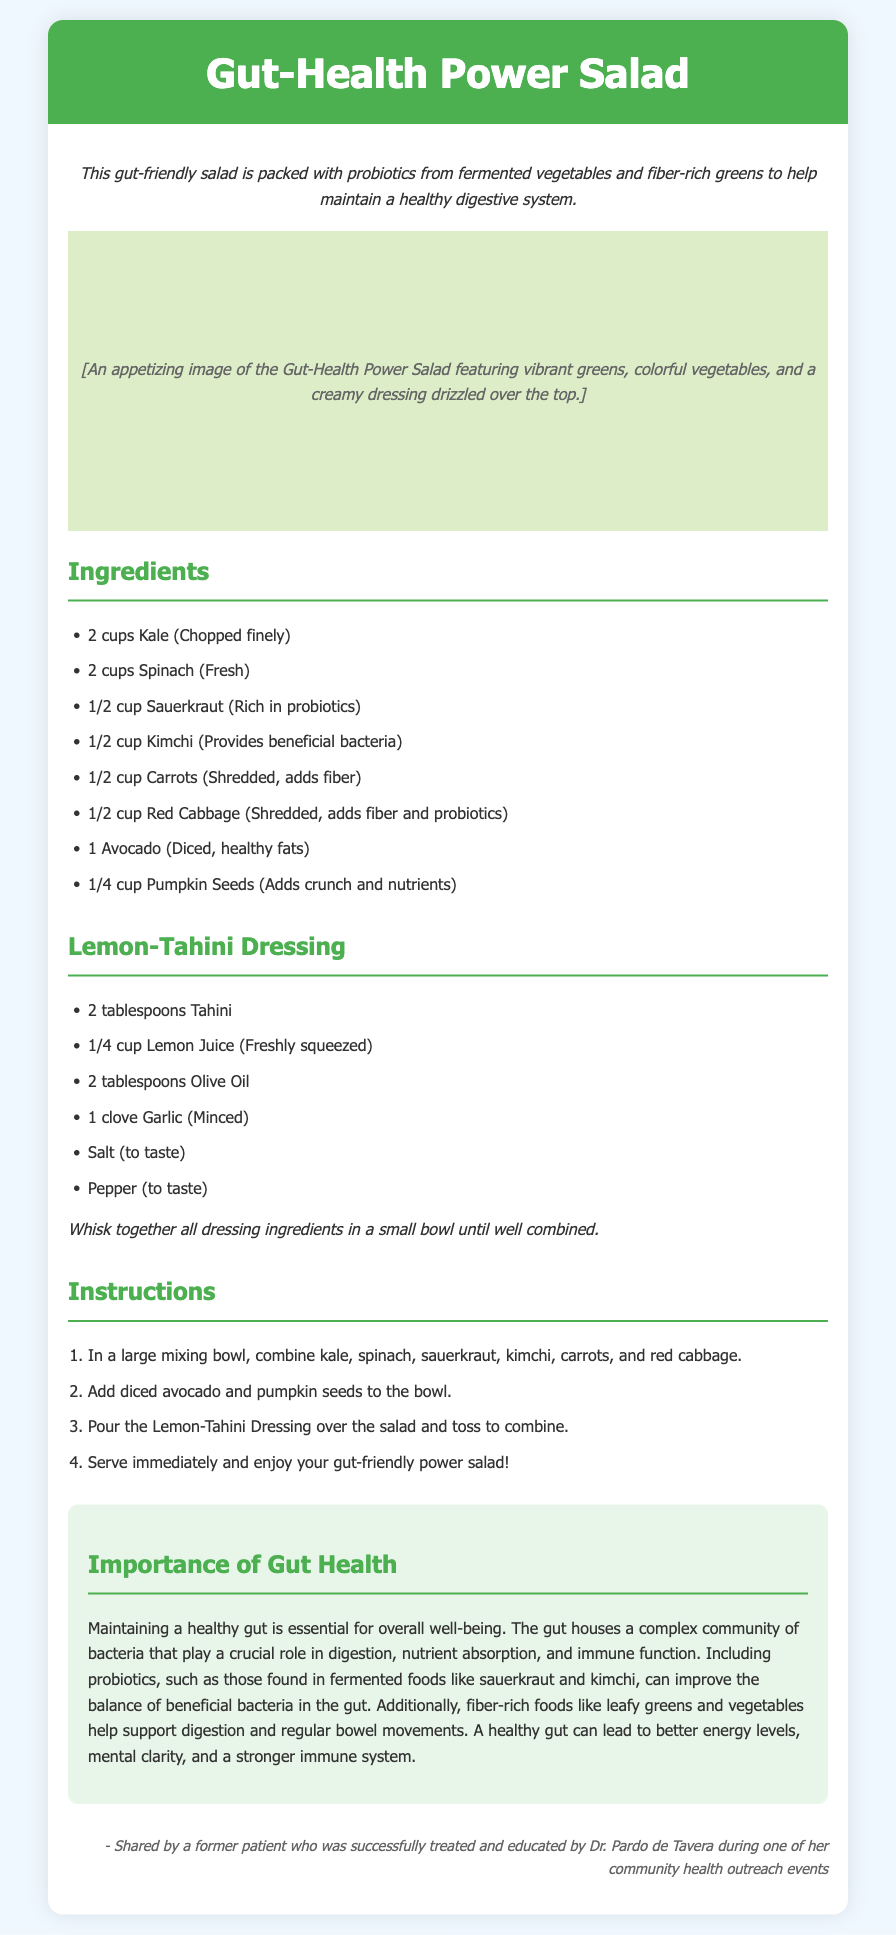what is the main ingredient that provides probiotics? Sauerkraut and kimchi are both listed as ingredients that are rich in probiotics.
Answer: Sauerkraut, Kimchi how many cups of kale are needed? The recipe specifies using 2 cups of chopped kale.
Answer: 2 cups what is the dressing used for the salad? The dressing is called Lemon-Tahini Dressing, which includes tahini, lemon juice, olive oil, and garlic.
Answer: Lemon-Tahini Dressing how many ingredients are listed in total for the salad? The ingredients section lists 8 main salad ingredients and 6 dressing ingredients, totaling 14.
Answer: 14 what is the importance of gut health mentioned? The document emphasizes that maintaining a healthy gut is essential for digestion, nutrient absorption, and immune function.
Answer: Essential for digestion, nutrient absorption, and immune function what ingredient adds healthy fats to the salad? The recipe includes diced avocado, which is known for its healthy fats.
Answer: Avocado how should the dressing be prepared? The instructions state to whisk together the dressing ingredients until well combined.
Answer: Whisk together what type of greens are included in the recipe? The recipe includes kale and spinach, both of which are leafy greens.
Answer: Kale, Spinach how many servings does the recipe approximate? The recipe does not specify the number of servings but is generally a large salad that could serve multiple people.
Answer: Not specified 